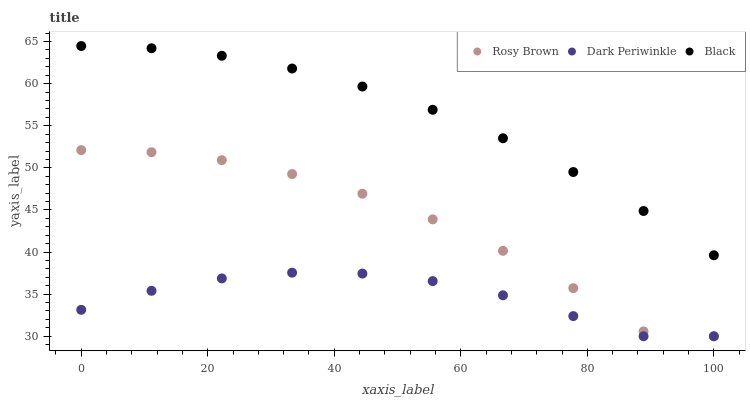Does Dark Periwinkle have the minimum area under the curve?
Answer yes or no. Yes. Does Black have the maximum area under the curve?
Answer yes or no. Yes. Does Black have the minimum area under the curve?
Answer yes or no. No. Does Dark Periwinkle have the maximum area under the curve?
Answer yes or no. No. Is Black the smoothest?
Answer yes or no. Yes. Is Rosy Brown the roughest?
Answer yes or no. Yes. Is Dark Periwinkle the smoothest?
Answer yes or no. No. Is Dark Periwinkle the roughest?
Answer yes or no. No. Does Rosy Brown have the lowest value?
Answer yes or no. Yes. Does Black have the lowest value?
Answer yes or no. No. Does Black have the highest value?
Answer yes or no. Yes. Does Dark Periwinkle have the highest value?
Answer yes or no. No. Is Dark Periwinkle less than Black?
Answer yes or no. Yes. Is Black greater than Dark Periwinkle?
Answer yes or no. Yes. Does Dark Periwinkle intersect Rosy Brown?
Answer yes or no. Yes. Is Dark Periwinkle less than Rosy Brown?
Answer yes or no. No. Is Dark Periwinkle greater than Rosy Brown?
Answer yes or no. No. Does Dark Periwinkle intersect Black?
Answer yes or no. No. 